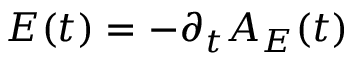Convert formula to latex. <formula><loc_0><loc_0><loc_500><loc_500>E ( t ) = - \partial _ { t } A _ { E } ( t )</formula> 